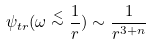<formula> <loc_0><loc_0><loc_500><loc_500>\psi _ { t r } ( \omega \stackrel { < } \sim \frac { 1 } { r } ) \sim \frac { 1 } { r ^ { 3 + n } }</formula> 